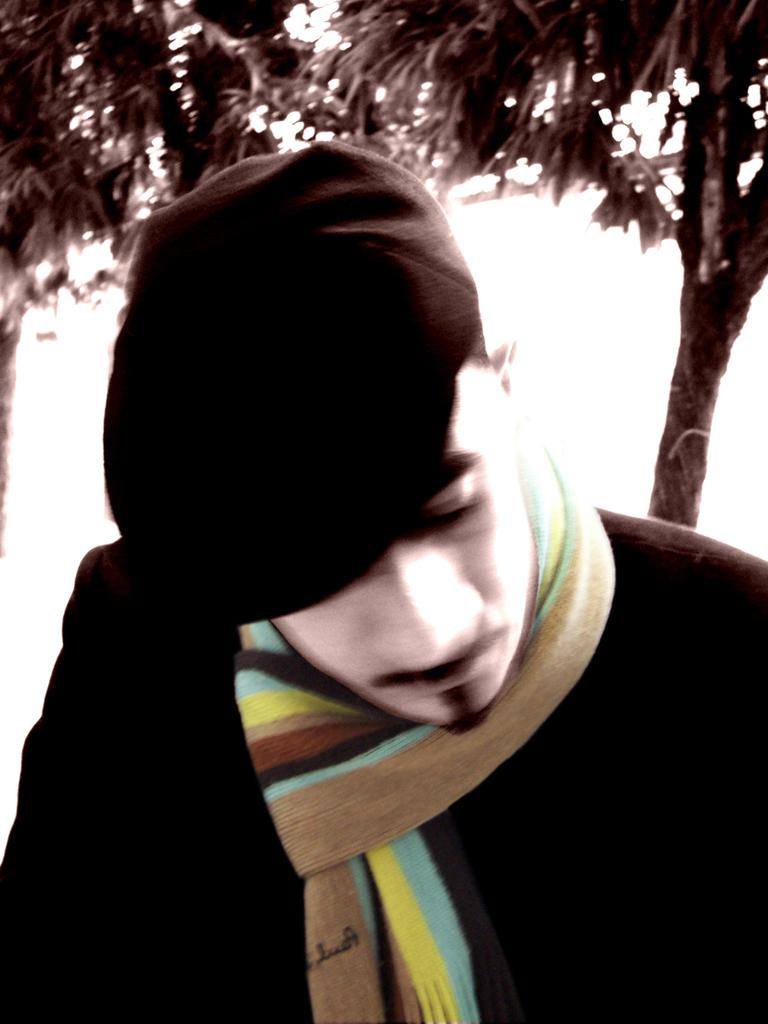Who is the main subject in the image? There is a man in the front of the image. What can be seen in the background of the image? There is a tree in the background of the image. What type of bulb is hanging from the tree in the image? There is no bulb present in the image; it only features a man in the front and a tree in the background. 